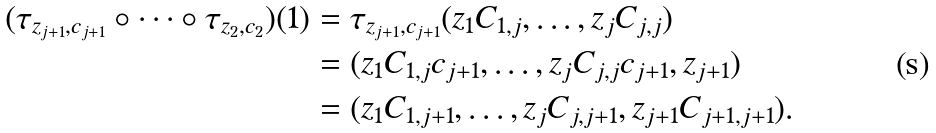Convert formula to latex. <formula><loc_0><loc_0><loc_500><loc_500>( \tau _ { z _ { j + 1 } , c _ { j + 1 } } \circ \cdots \circ \tau _ { z _ { 2 } , c _ { 2 } } ) ( 1 ) & = \tau _ { z _ { j + 1 } , c _ { j + 1 } } ( z _ { 1 } C _ { 1 , j } , \dots , z _ { j } C _ { j , j } ) \\ & = ( z _ { 1 } C _ { 1 , j } c _ { j + 1 } , \dots , z _ { j } C _ { j , j } c _ { j + 1 } , z _ { j + 1 } ) \\ & = ( z _ { 1 } C _ { 1 , j + 1 } , \dots , z _ { j } C _ { j , j + 1 } , z _ { j + 1 } C _ { j + 1 , j + 1 } ) .</formula> 